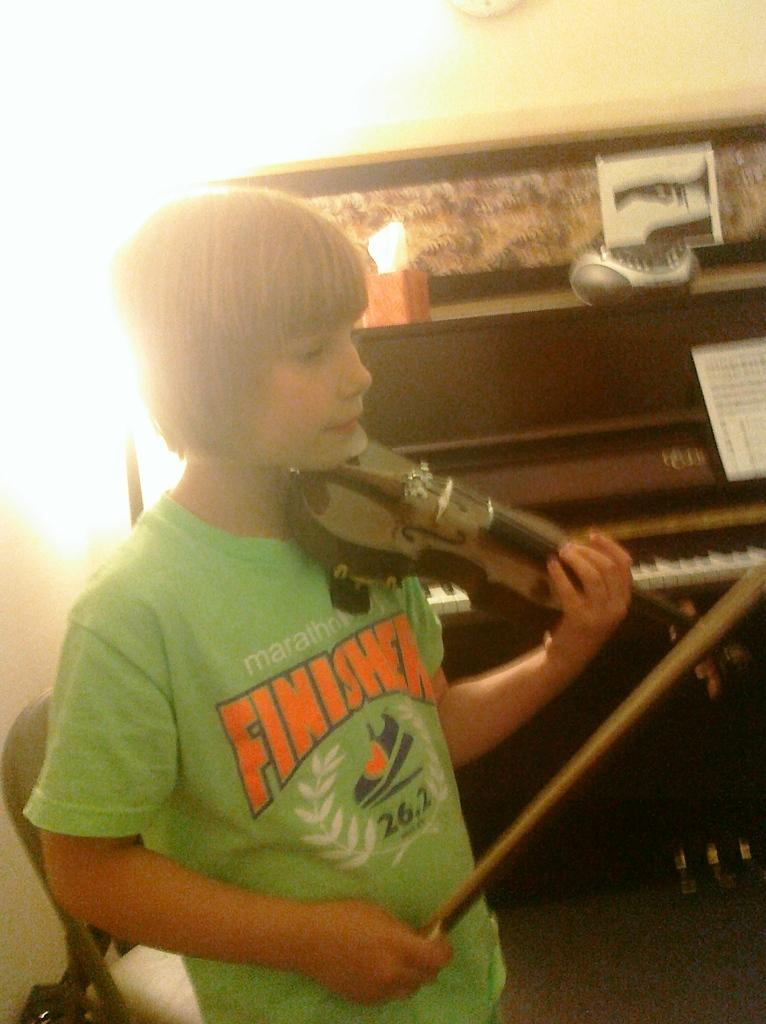Who is the main subject in the image? There is a boy in the image. What is the boy holding in his hand? The boy is holding a violin in his hand. What can be seen in the background of the image? There is a piano and a wall in the background of the image. What type of twig is the boy using to play the violin in the image? There is no twig present in the image; the boy is holding a violin, not a twig. 